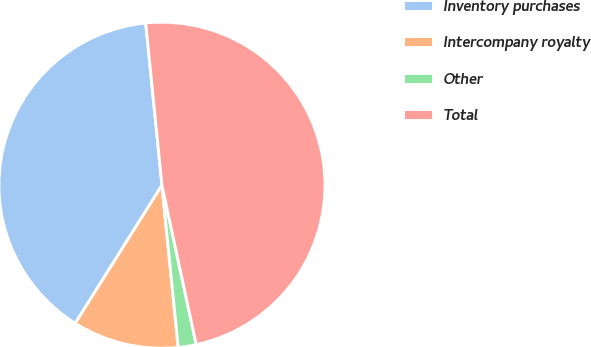Convert chart. <chart><loc_0><loc_0><loc_500><loc_500><pie_chart><fcel>Inventory purchases<fcel>Intercompany royalty<fcel>Other<fcel>Total<nl><fcel>39.48%<fcel>10.52%<fcel>1.78%<fcel>48.22%<nl></chart> 